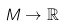Convert formula to latex. <formula><loc_0><loc_0><loc_500><loc_500>M \to \mathbb { R }</formula> 